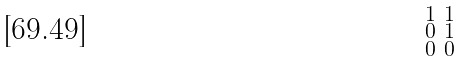<formula> <loc_0><loc_0><loc_500><loc_500>\begin{smallmatrix} 1 & 1 \\ 0 & 1 \\ 0 & 0 \end{smallmatrix}</formula> 